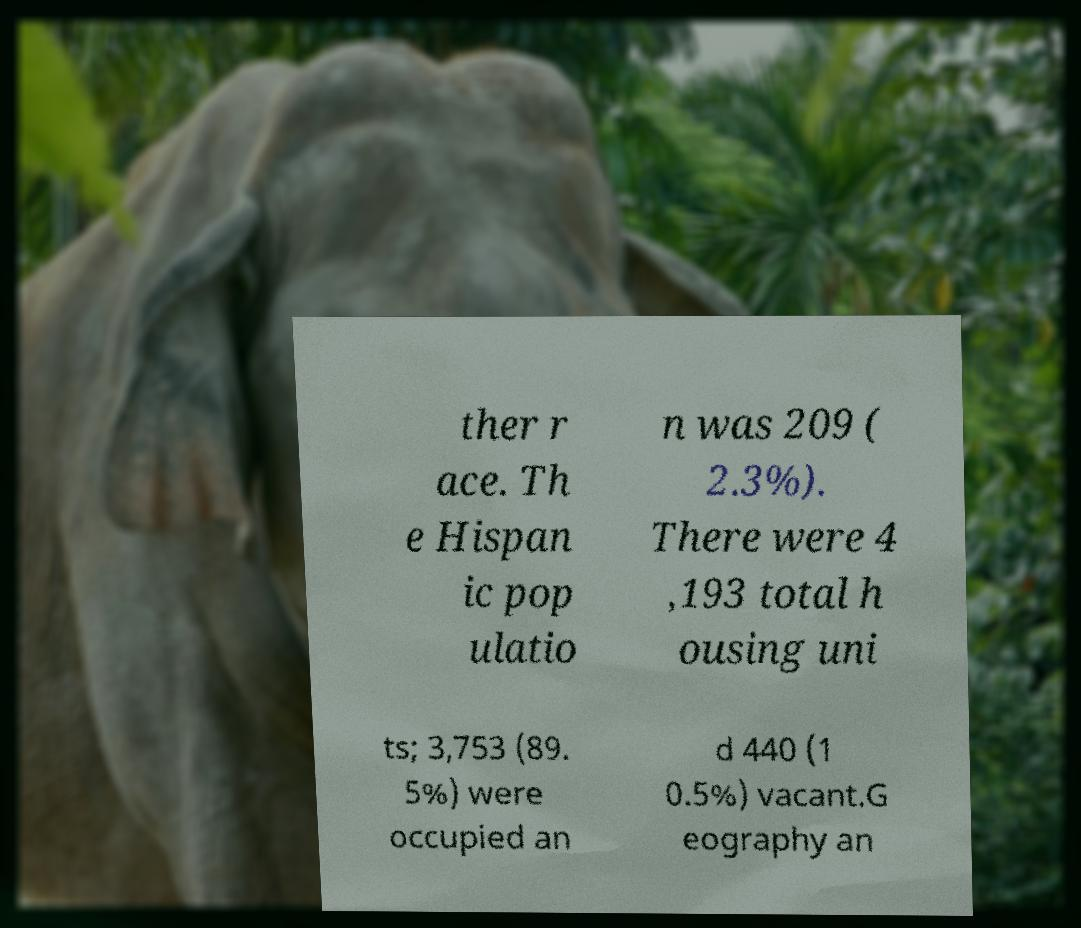What messages or text are displayed in this image? I need them in a readable, typed format. ther r ace. Th e Hispan ic pop ulatio n was 209 ( 2.3%). There were 4 ,193 total h ousing uni ts; 3,753 (89. 5%) were occupied an d 440 (1 0.5%) vacant.G eography an 